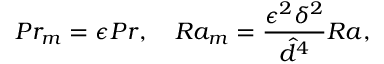<formula> <loc_0><loc_0><loc_500><loc_500>P r _ { m } = \epsilon P r , \quad R a _ { m } = \frac { \epsilon ^ { 2 } \delta ^ { 2 } } { \hat { d } ^ { 4 } } R a ,</formula> 